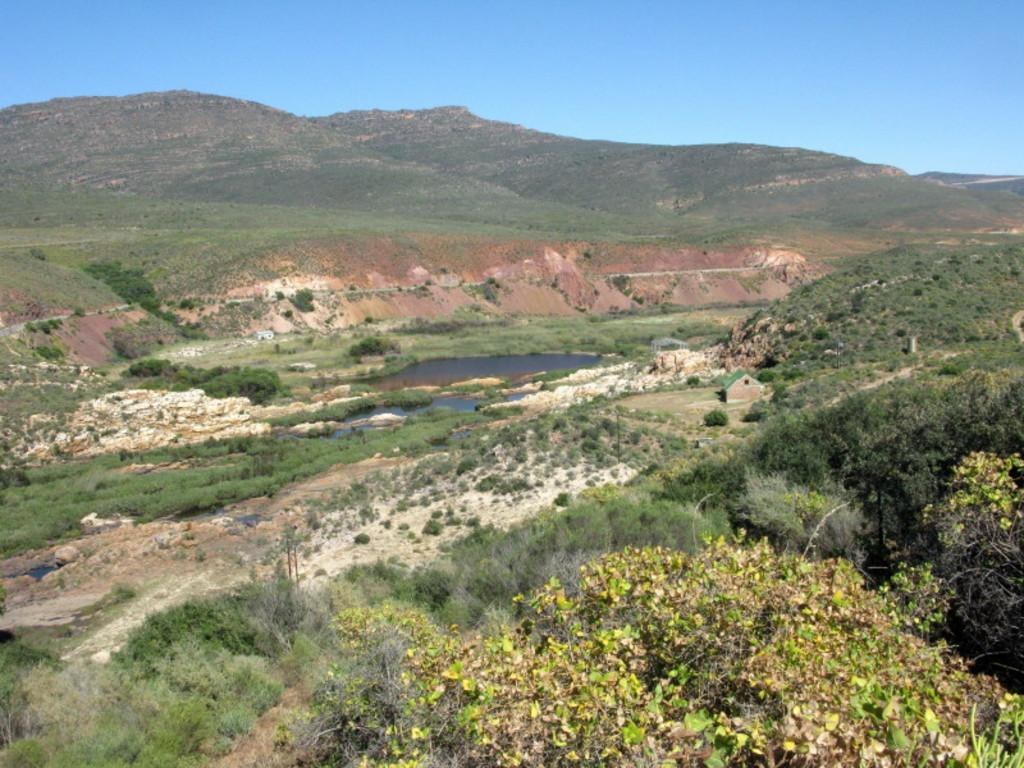What type of vegetation can be seen in the image? There are many plants and trees in the image. What is the primary element visible in the image? Water is visible in the image. What type of structure is present in the image? There is a house in the image. What can be seen in the background of the image? The background of the image includes hills and the sky. What color is the cap that the person is wearing in the image? There is no person wearing a cap in the image; it primarily features plants, water, trees, a house, hills, and the sky. What type of silverware is present in the lunchroom in the image? There is no lunchroom or silverware present in the image. 